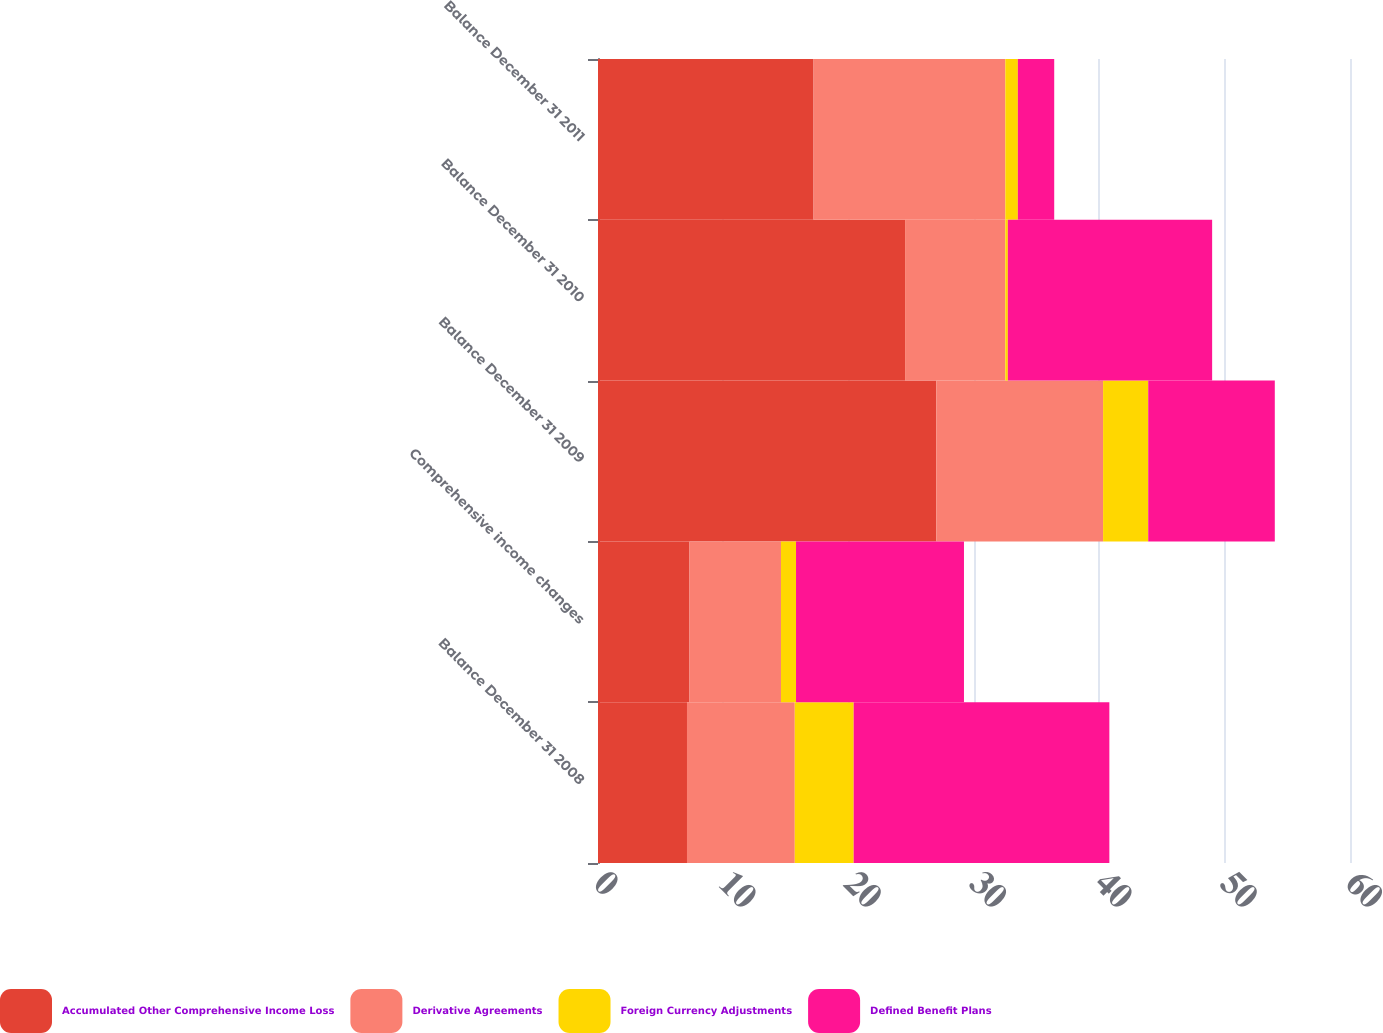Convert chart. <chart><loc_0><loc_0><loc_500><loc_500><stacked_bar_chart><ecel><fcel>Balance December 31 2008<fcel>Comprehensive income changes<fcel>Balance December 31 2009<fcel>Balance December 31 2010<fcel>Balance December 31 2011<nl><fcel>Accumulated Other Comprehensive Income Loss<fcel>7.1<fcel>7.3<fcel>27<fcel>24.5<fcel>17.2<nl><fcel>Derivative Agreements<fcel>8.6<fcel>7.3<fcel>13.3<fcel>8<fcel>15.3<nl><fcel>Foreign Currency Adjustments<fcel>4.7<fcel>1.2<fcel>3.6<fcel>0.2<fcel>1<nl><fcel>Defined Benefit Plans<fcel>20.4<fcel>13.4<fcel>10.1<fcel>16.3<fcel>2.9<nl></chart> 